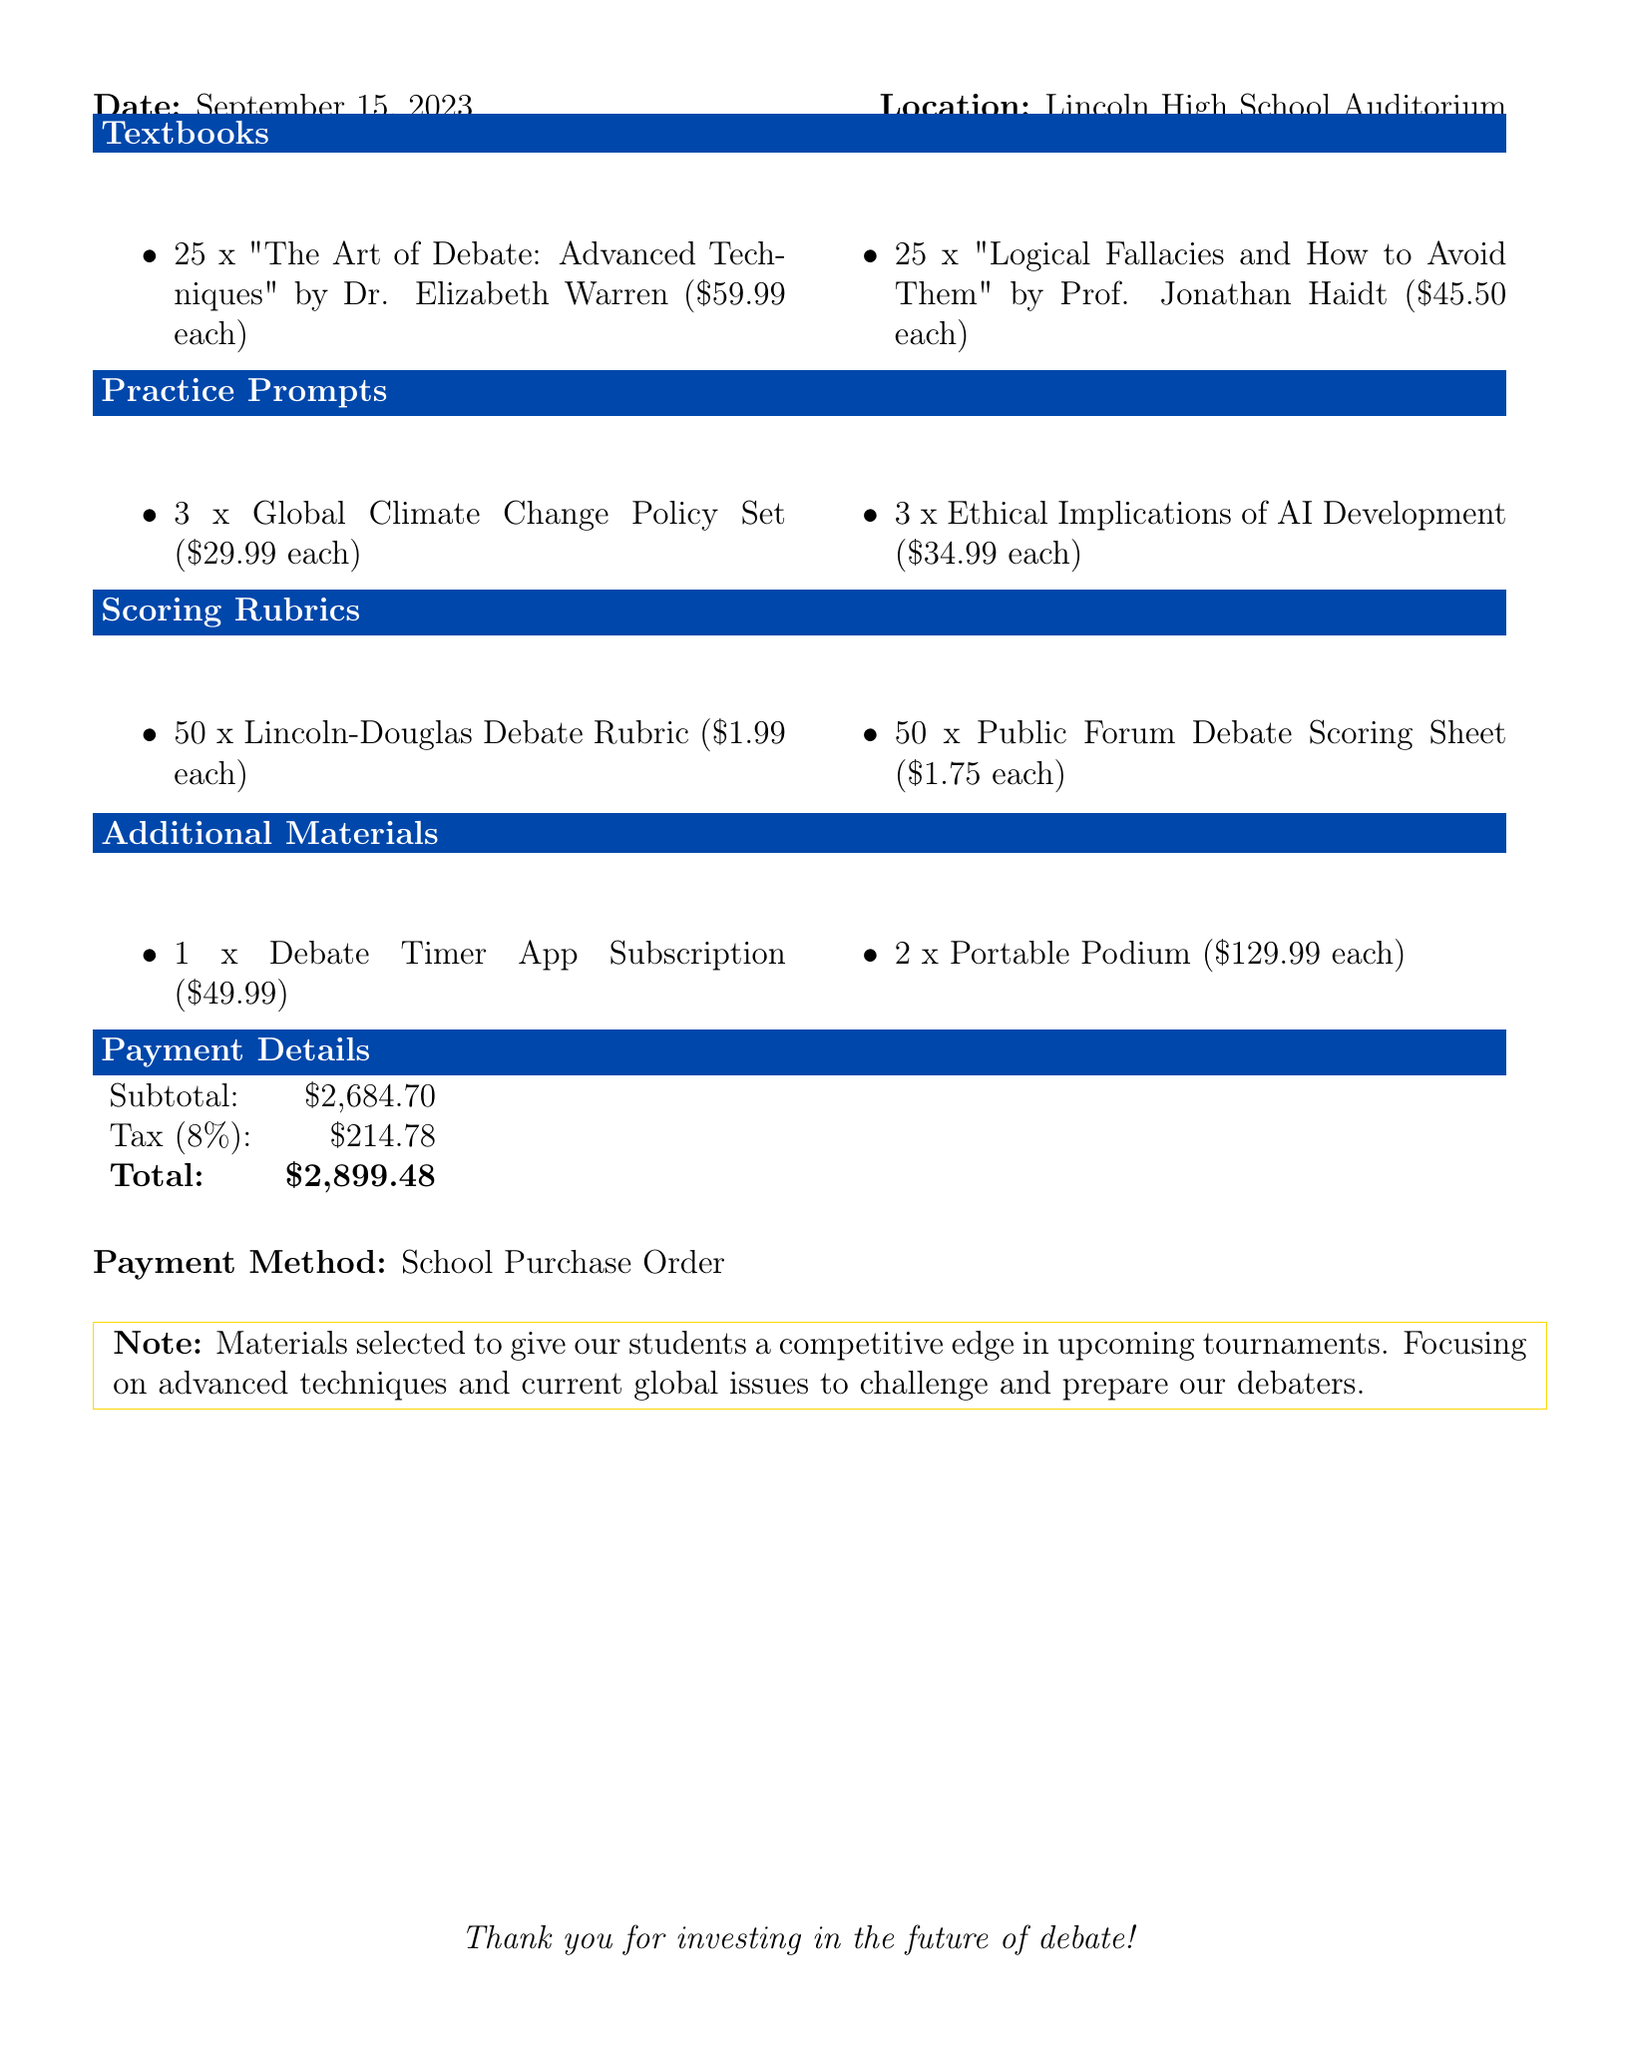What is the date of the workshop? The date of the workshop is explicitly mentioned in the document.
Answer: September 15, 2023 Where is the workshop located? The location of the workshop is stated in the document.
Answer: Lincoln High School Auditorium Who is the author of "The Art of Debate: Advanced Techniques"? The document specifies the author for each textbook listed.
Answer: Dr. Elizabeth Warren How many Lincoln-Douglas Debate Rubrics were purchased? The quantity of each scoring rubric purchased is included in the document.
Answer: 50 What is the unit price of the Portable Podium? The document provides the unit price for each additional material item.
Answer: 129.99 What is the subtotal amount? The subtotal is provided in the payment details section of the document.
Answer: 2,684.70 Which supplier provided the Ethical Implications of AI Development practice prompt? The supplier for each practice prompt is identified in the document.
Answer: International Debate Education Association What payment method was used for the purchase? The payment method is clearly stated in the payment details.
Answer: School Purchase Order What is the total cost including tax? The total includes the subtotal and added tax from the payment details.
Answer: 2,899.48 